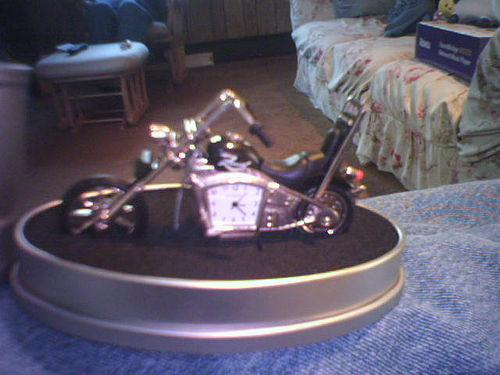What best describes the size of the motorcycle? Please explain your reasoning. miniature. The size is tiny. 